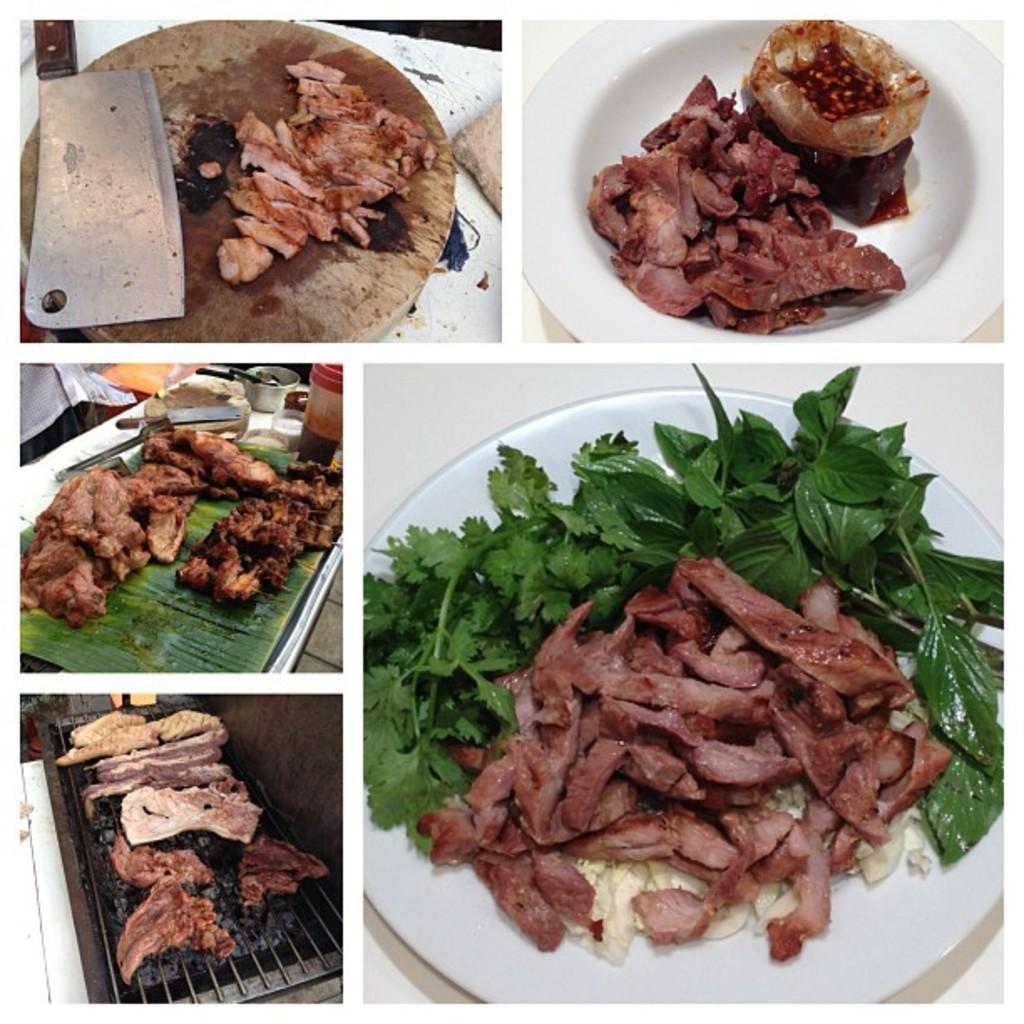In one or two sentences, can you explain what this image depicts? This is a collage, in this image on the right side there are two plates. In the plates there is some food and on the left side there is one knife, board, leaf and grill machine. On this things there is some meat. 